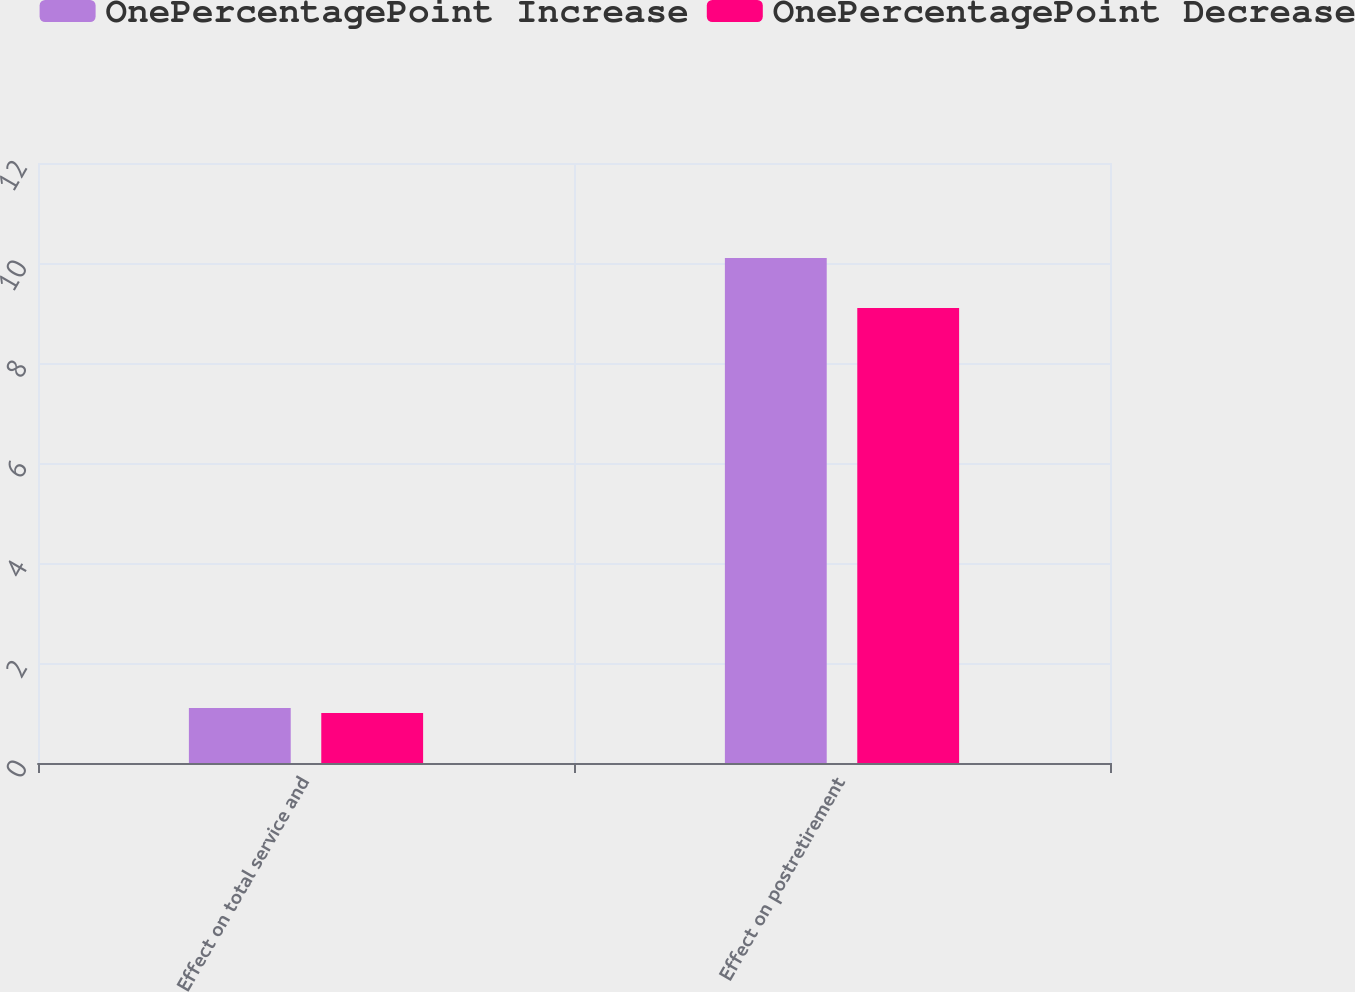Convert chart to OTSL. <chart><loc_0><loc_0><loc_500><loc_500><stacked_bar_chart><ecel><fcel>Effect on total service and<fcel>Effect on postretirement<nl><fcel>OnePercentagePoint Increase<fcel>1.1<fcel>10.1<nl><fcel>OnePercentagePoint Decrease<fcel>1<fcel>9.1<nl></chart> 